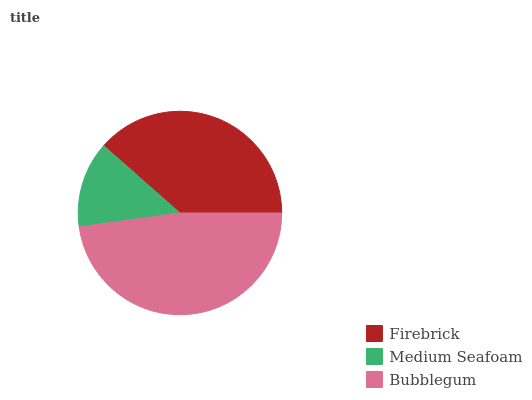Is Medium Seafoam the minimum?
Answer yes or no. Yes. Is Bubblegum the maximum?
Answer yes or no. Yes. Is Bubblegum the minimum?
Answer yes or no. No. Is Medium Seafoam the maximum?
Answer yes or no. No. Is Bubblegum greater than Medium Seafoam?
Answer yes or no. Yes. Is Medium Seafoam less than Bubblegum?
Answer yes or no. Yes. Is Medium Seafoam greater than Bubblegum?
Answer yes or no. No. Is Bubblegum less than Medium Seafoam?
Answer yes or no. No. Is Firebrick the high median?
Answer yes or no. Yes. Is Firebrick the low median?
Answer yes or no. Yes. Is Bubblegum the high median?
Answer yes or no. No. Is Bubblegum the low median?
Answer yes or no. No. 